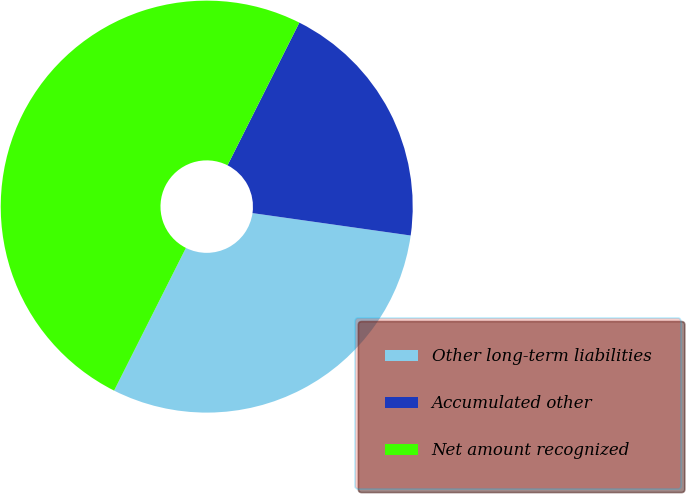Convert chart. <chart><loc_0><loc_0><loc_500><loc_500><pie_chart><fcel>Other long-term liabilities<fcel>Accumulated other<fcel>Net amount recognized<nl><fcel>30.18%<fcel>19.82%<fcel>50.0%<nl></chart> 